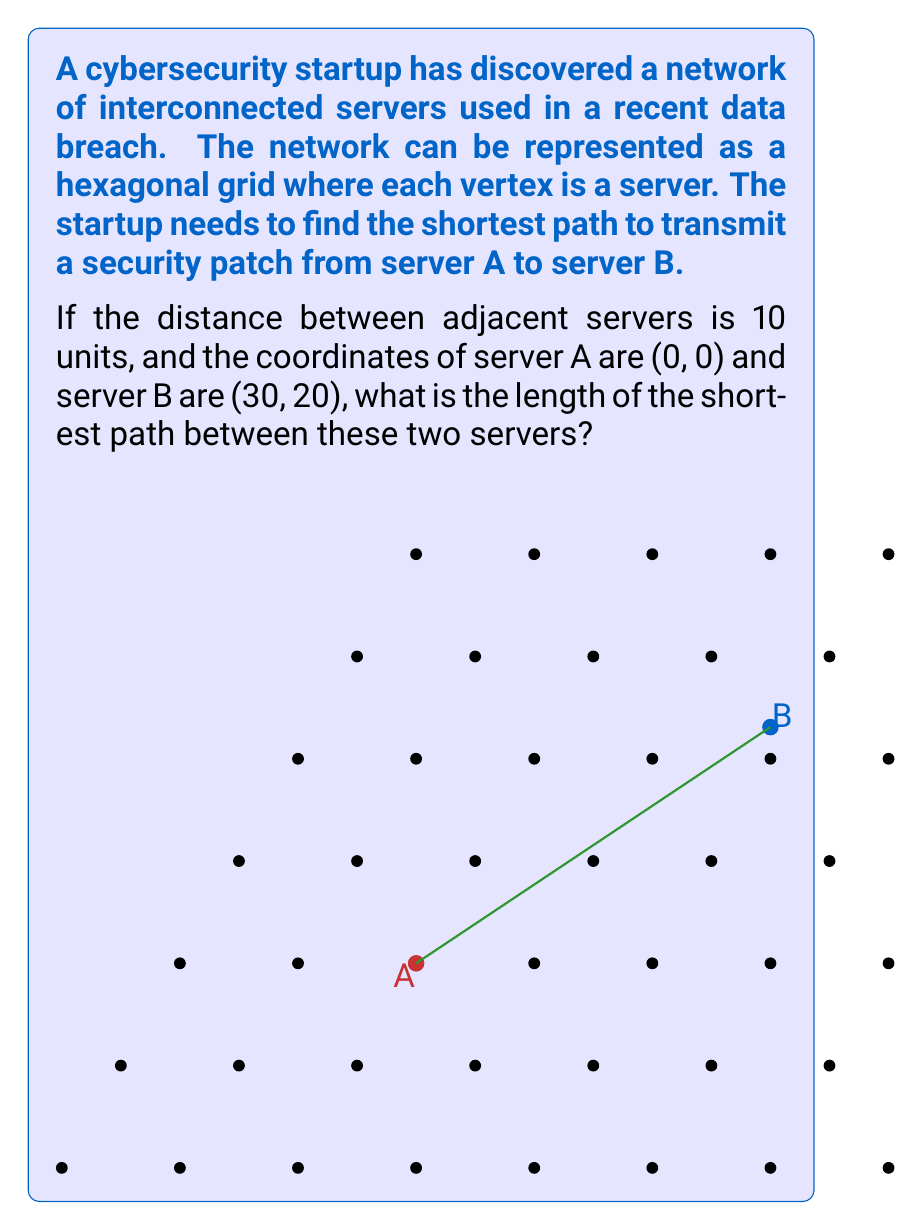Show me your answer to this math problem. To solve this problem, we can use the concept of hexagonal grids and their geometric properties:

1) In a hexagonal grid, we can use a coordinate system where each step in the x-direction is 10 units, and each step in the y-direction is $10 \cdot \frac{\sqrt{3}}{2} \approx 8.66$ units.

2) The coordinates given are in terms of these steps. So, server B is 3 steps in the x-direction and 2 steps in the y-direction from server A.

3) In a hexagonal grid, the shortest path between two points is not always a straight line. Instead, we need to count the minimum number of hexagon edges we need to traverse.

4) To find this, we can use the formula:
   $$\text{distance} = \max(|\Delta x|, |\Delta y|, |\Delta x - \Delta y|)$$
   Where $\Delta x$ and $\Delta y$ are the differences in x and y coordinates respectively.

5) In this case:
   $\Delta x = 3$
   $\Delta y = 2$
   $|\Delta x - \Delta y| = |3 - 2| = 1$

6) Therefore, the number of steps in the shortest path is:
   $$\max(3, 2, 1) = 3$$

7) Since each step is 10 units, the total length of the shortest path is:
   $$3 \cdot 10 = 30 \text{ units}$$
Answer: 30 units 